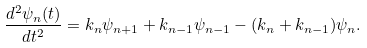Convert formula to latex. <formula><loc_0><loc_0><loc_500><loc_500>\frac { d ^ { 2 } \psi _ { n } ( t ) } { d t ^ { 2 } } = k _ { n } \psi _ { n + 1 } + k _ { n - 1 } \psi _ { n - 1 } - ( k _ { n } + k _ { n - 1 } ) \psi _ { n } .</formula> 